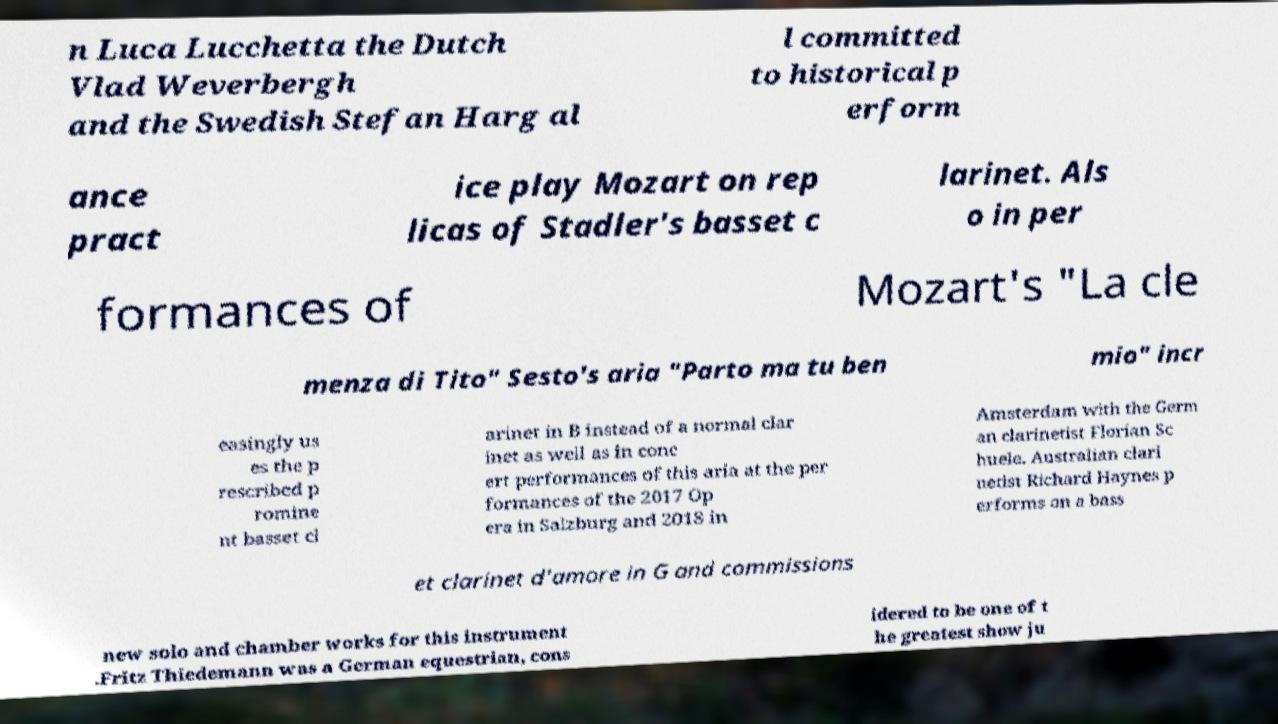There's text embedded in this image that I need extracted. Can you transcribe it verbatim? n Luca Lucchetta the Dutch Vlad Weverbergh and the Swedish Stefan Harg al l committed to historical p erform ance pract ice play Mozart on rep licas of Stadler's basset c larinet. Als o in per formances of Mozart's "La cle menza di Tito" Sesto's aria "Parto ma tu ben mio" incr easingly us es the p rescribed p romine nt basset cl arinet in B instead of a normal clar inet as well as in conc ert performances of this aria at the per formances of the 2017 Op era in Salzburg and 2018 in Amsterdam with the Germ an clarinetist Florian Sc huele. Australian clari netist Richard Haynes p erforms on a bass et clarinet d'amore in G and commissions new solo and chamber works for this instrument .Fritz Thiedemann was a German equestrian, cons idered to be one of t he greatest show ju 